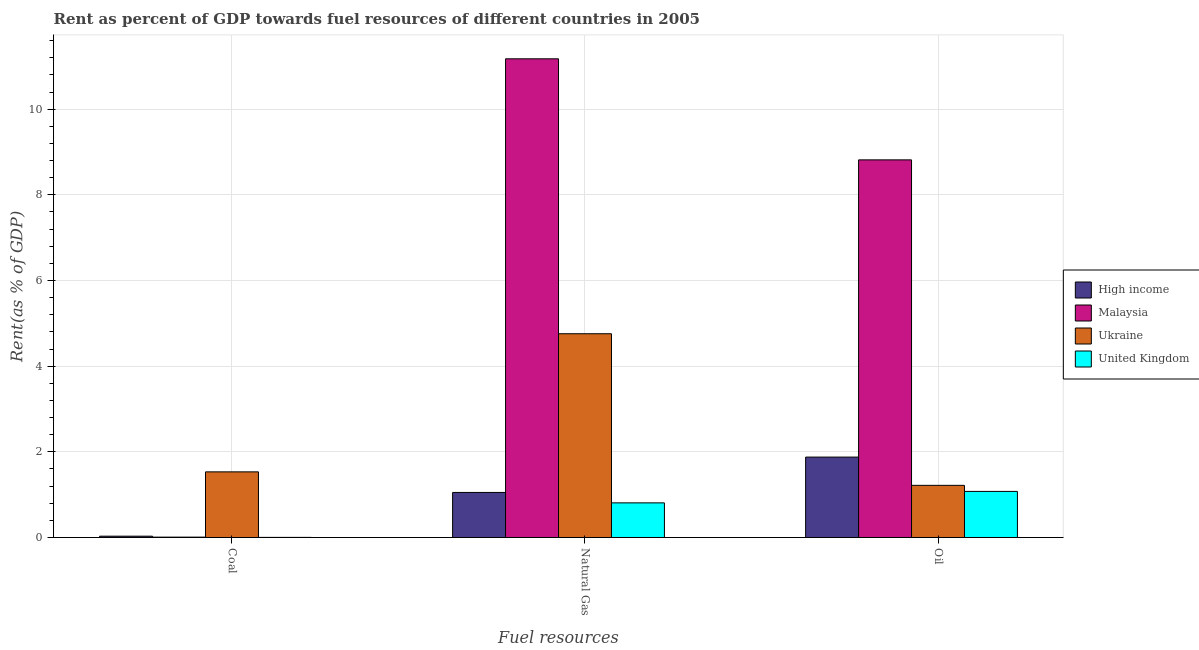How many bars are there on the 1st tick from the left?
Offer a very short reply. 4. What is the label of the 1st group of bars from the left?
Ensure brevity in your answer.  Coal. What is the rent towards coal in United Kingdom?
Make the answer very short. 0. Across all countries, what is the maximum rent towards coal?
Keep it short and to the point. 1.53. Across all countries, what is the minimum rent towards oil?
Offer a terse response. 1.08. In which country was the rent towards oil maximum?
Make the answer very short. Malaysia. What is the total rent towards natural gas in the graph?
Offer a very short reply. 17.79. What is the difference between the rent towards coal in Ukraine and that in Malaysia?
Give a very brief answer. 1.52. What is the difference between the rent towards natural gas in Ukraine and the rent towards oil in United Kingdom?
Provide a short and direct response. 3.68. What is the average rent towards natural gas per country?
Keep it short and to the point. 4.45. What is the difference between the rent towards coal and rent towards natural gas in Malaysia?
Give a very brief answer. -11.17. In how many countries, is the rent towards oil greater than 0.4 %?
Make the answer very short. 4. What is the ratio of the rent towards natural gas in High income to that in Malaysia?
Offer a very short reply. 0.09. Is the rent towards natural gas in United Kingdom less than that in Ukraine?
Keep it short and to the point. Yes. Is the difference between the rent towards coal in High income and United Kingdom greater than the difference between the rent towards natural gas in High income and United Kingdom?
Provide a short and direct response. No. What is the difference between the highest and the second highest rent towards oil?
Ensure brevity in your answer.  6.94. What is the difference between the highest and the lowest rent towards natural gas?
Give a very brief answer. 10.37. What does the 2nd bar from the left in Natural Gas represents?
Provide a short and direct response. Malaysia. What does the 2nd bar from the right in Oil represents?
Your response must be concise. Ukraine. Is it the case that in every country, the sum of the rent towards coal and rent towards natural gas is greater than the rent towards oil?
Give a very brief answer. No. How many bars are there?
Provide a short and direct response. 12. How many countries are there in the graph?
Provide a short and direct response. 4. What is the difference between two consecutive major ticks on the Y-axis?
Make the answer very short. 2. Does the graph contain any zero values?
Offer a very short reply. No. Where does the legend appear in the graph?
Provide a succinct answer. Center right. How many legend labels are there?
Offer a terse response. 4. How are the legend labels stacked?
Your answer should be very brief. Vertical. What is the title of the graph?
Make the answer very short. Rent as percent of GDP towards fuel resources of different countries in 2005. What is the label or title of the X-axis?
Offer a terse response. Fuel resources. What is the label or title of the Y-axis?
Give a very brief answer. Rent(as % of GDP). What is the Rent(as % of GDP) in High income in Coal?
Provide a succinct answer. 0.03. What is the Rent(as % of GDP) in Malaysia in Coal?
Your response must be concise. 0.01. What is the Rent(as % of GDP) of Ukraine in Coal?
Your response must be concise. 1.53. What is the Rent(as % of GDP) in United Kingdom in Coal?
Offer a terse response. 0. What is the Rent(as % of GDP) in High income in Natural Gas?
Your response must be concise. 1.05. What is the Rent(as % of GDP) of Malaysia in Natural Gas?
Give a very brief answer. 11.18. What is the Rent(as % of GDP) in Ukraine in Natural Gas?
Ensure brevity in your answer.  4.76. What is the Rent(as % of GDP) in United Kingdom in Natural Gas?
Offer a very short reply. 0.81. What is the Rent(as % of GDP) of High income in Oil?
Give a very brief answer. 1.88. What is the Rent(as % of GDP) in Malaysia in Oil?
Offer a terse response. 8.82. What is the Rent(as % of GDP) of Ukraine in Oil?
Offer a very short reply. 1.22. What is the Rent(as % of GDP) in United Kingdom in Oil?
Keep it short and to the point. 1.08. Across all Fuel resources, what is the maximum Rent(as % of GDP) of High income?
Give a very brief answer. 1.88. Across all Fuel resources, what is the maximum Rent(as % of GDP) of Malaysia?
Ensure brevity in your answer.  11.18. Across all Fuel resources, what is the maximum Rent(as % of GDP) in Ukraine?
Offer a terse response. 4.76. Across all Fuel resources, what is the maximum Rent(as % of GDP) of United Kingdom?
Provide a short and direct response. 1.08. Across all Fuel resources, what is the minimum Rent(as % of GDP) in High income?
Keep it short and to the point. 0.03. Across all Fuel resources, what is the minimum Rent(as % of GDP) of Malaysia?
Provide a short and direct response. 0.01. Across all Fuel resources, what is the minimum Rent(as % of GDP) of Ukraine?
Your response must be concise. 1.22. Across all Fuel resources, what is the minimum Rent(as % of GDP) in United Kingdom?
Offer a very short reply. 0. What is the total Rent(as % of GDP) in High income in the graph?
Offer a terse response. 2.96. What is the total Rent(as % of GDP) of Malaysia in the graph?
Your answer should be compact. 20. What is the total Rent(as % of GDP) in Ukraine in the graph?
Your answer should be compact. 7.51. What is the total Rent(as % of GDP) of United Kingdom in the graph?
Make the answer very short. 1.89. What is the difference between the Rent(as % of GDP) of High income in Coal and that in Natural Gas?
Your answer should be very brief. -1.02. What is the difference between the Rent(as % of GDP) in Malaysia in Coal and that in Natural Gas?
Provide a short and direct response. -11.17. What is the difference between the Rent(as % of GDP) of Ukraine in Coal and that in Natural Gas?
Provide a succinct answer. -3.22. What is the difference between the Rent(as % of GDP) of United Kingdom in Coal and that in Natural Gas?
Make the answer very short. -0.81. What is the difference between the Rent(as % of GDP) in High income in Coal and that in Oil?
Your answer should be very brief. -1.85. What is the difference between the Rent(as % of GDP) of Malaysia in Coal and that in Oil?
Provide a succinct answer. -8.81. What is the difference between the Rent(as % of GDP) of Ukraine in Coal and that in Oil?
Offer a very short reply. 0.31. What is the difference between the Rent(as % of GDP) of United Kingdom in Coal and that in Oil?
Make the answer very short. -1.07. What is the difference between the Rent(as % of GDP) of High income in Natural Gas and that in Oil?
Your response must be concise. -0.83. What is the difference between the Rent(as % of GDP) of Malaysia in Natural Gas and that in Oil?
Offer a very short reply. 2.36. What is the difference between the Rent(as % of GDP) in Ukraine in Natural Gas and that in Oil?
Ensure brevity in your answer.  3.54. What is the difference between the Rent(as % of GDP) in United Kingdom in Natural Gas and that in Oil?
Give a very brief answer. -0.27. What is the difference between the Rent(as % of GDP) of High income in Coal and the Rent(as % of GDP) of Malaysia in Natural Gas?
Keep it short and to the point. -11.14. What is the difference between the Rent(as % of GDP) in High income in Coal and the Rent(as % of GDP) in Ukraine in Natural Gas?
Offer a terse response. -4.73. What is the difference between the Rent(as % of GDP) in High income in Coal and the Rent(as % of GDP) in United Kingdom in Natural Gas?
Ensure brevity in your answer.  -0.78. What is the difference between the Rent(as % of GDP) in Malaysia in Coal and the Rent(as % of GDP) in Ukraine in Natural Gas?
Make the answer very short. -4.75. What is the difference between the Rent(as % of GDP) in Malaysia in Coal and the Rent(as % of GDP) in United Kingdom in Natural Gas?
Make the answer very short. -0.8. What is the difference between the Rent(as % of GDP) in Ukraine in Coal and the Rent(as % of GDP) in United Kingdom in Natural Gas?
Offer a very short reply. 0.72. What is the difference between the Rent(as % of GDP) of High income in Coal and the Rent(as % of GDP) of Malaysia in Oil?
Provide a short and direct response. -8.79. What is the difference between the Rent(as % of GDP) of High income in Coal and the Rent(as % of GDP) of Ukraine in Oil?
Ensure brevity in your answer.  -1.19. What is the difference between the Rent(as % of GDP) in High income in Coal and the Rent(as % of GDP) in United Kingdom in Oil?
Your answer should be very brief. -1.05. What is the difference between the Rent(as % of GDP) of Malaysia in Coal and the Rent(as % of GDP) of Ukraine in Oil?
Provide a succinct answer. -1.21. What is the difference between the Rent(as % of GDP) of Malaysia in Coal and the Rent(as % of GDP) of United Kingdom in Oil?
Ensure brevity in your answer.  -1.07. What is the difference between the Rent(as % of GDP) in Ukraine in Coal and the Rent(as % of GDP) in United Kingdom in Oil?
Give a very brief answer. 0.46. What is the difference between the Rent(as % of GDP) of High income in Natural Gas and the Rent(as % of GDP) of Malaysia in Oil?
Your response must be concise. -7.76. What is the difference between the Rent(as % of GDP) in High income in Natural Gas and the Rent(as % of GDP) in Ukraine in Oil?
Ensure brevity in your answer.  -0.17. What is the difference between the Rent(as % of GDP) of High income in Natural Gas and the Rent(as % of GDP) of United Kingdom in Oil?
Provide a short and direct response. -0.02. What is the difference between the Rent(as % of GDP) in Malaysia in Natural Gas and the Rent(as % of GDP) in Ukraine in Oil?
Your answer should be compact. 9.96. What is the difference between the Rent(as % of GDP) of Malaysia in Natural Gas and the Rent(as % of GDP) of United Kingdom in Oil?
Your response must be concise. 10.1. What is the difference between the Rent(as % of GDP) of Ukraine in Natural Gas and the Rent(as % of GDP) of United Kingdom in Oil?
Give a very brief answer. 3.68. What is the average Rent(as % of GDP) in High income per Fuel resources?
Your answer should be very brief. 0.99. What is the average Rent(as % of GDP) of Malaysia per Fuel resources?
Offer a very short reply. 6.67. What is the average Rent(as % of GDP) of Ukraine per Fuel resources?
Your response must be concise. 2.5. What is the average Rent(as % of GDP) in United Kingdom per Fuel resources?
Give a very brief answer. 0.63. What is the difference between the Rent(as % of GDP) in High income and Rent(as % of GDP) in Malaysia in Coal?
Offer a terse response. 0.02. What is the difference between the Rent(as % of GDP) in High income and Rent(as % of GDP) in Ukraine in Coal?
Provide a short and direct response. -1.5. What is the difference between the Rent(as % of GDP) in High income and Rent(as % of GDP) in United Kingdom in Coal?
Give a very brief answer. 0.03. What is the difference between the Rent(as % of GDP) of Malaysia and Rent(as % of GDP) of Ukraine in Coal?
Your answer should be very brief. -1.52. What is the difference between the Rent(as % of GDP) in Malaysia and Rent(as % of GDP) in United Kingdom in Coal?
Ensure brevity in your answer.  0.01. What is the difference between the Rent(as % of GDP) in Ukraine and Rent(as % of GDP) in United Kingdom in Coal?
Ensure brevity in your answer.  1.53. What is the difference between the Rent(as % of GDP) of High income and Rent(as % of GDP) of Malaysia in Natural Gas?
Keep it short and to the point. -10.12. What is the difference between the Rent(as % of GDP) of High income and Rent(as % of GDP) of Ukraine in Natural Gas?
Your response must be concise. -3.7. What is the difference between the Rent(as % of GDP) of High income and Rent(as % of GDP) of United Kingdom in Natural Gas?
Your answer should be compact. 0.24. What is the difference between the Rent(as % of GDP) of Malaysia and Rent(as % of GDP) of Ukraine in Natural Gas?
Give a very brief answer. 6.42. What is the difference between the Rent(as % of GDP) in Malaysia and Rent(as % of GDP) in United Kingdom in Natural Gas?
Provide a short and direct response. 10.37. What is the difference between the Rent(as % of GDP) of Ukraine and Rent(as % of GDP) of United Kingdom in Natural Gas?
Ensure brevity in your answer.  3.95. What is the difference between the Rent(as % of GDP) in High income and Rent(as % of GDP) in Malaysia in Oil?
Your answer should be compact. -6.94. What is the difference between the Rent(as % of GDP) in High income and Rent(as % of GDP) in Ukraine in Oil?
Offer a very short reply. 0.66. What is the difference between the Rent(as % of GDP) of High income and Rent(as % of GDP) of United Kingdom in Oil?
Offer a very short reply. 0.8. What is the difference between the Rent(as % of GDP) of Malaysia and Rent(as % of GDP) of Ukraine in Oil?
Offer a very short reply. 7.6. What is the difference between the Rent(as % of GDP) of Malaysia and Rent(as % of GDP) of United Kingdom in Oil?
Keep it short and to the point. 7.74. What is the difference between the Rent(as % of GDP) in Ukraine and Rent(as % of GDP) in United Kingdom in Oil?
Offer a very short reply. 0.14. What is the ratio of the Rent(as % of GDP) of High income in Coal to that in Natural Gas?
Offer a very short reply. 0.03. What is the ratio of the Rent(as % of GDP) in Malaysia in Coal to that in Natural Gas?
Ensure brevity in your answer.  0. What is the ratio of the Rent(as % of GDP) in Ukraine in Coal to that in Natural Gas?
Keep it short and to the point. 0.32. What is the ratio of the Rent(as % of GDP) in United Kingdom in Coal to that in Natural Gas?
Your response must be concise. 0. What is the ratio of the Rent(as % of GDP) of High income in Coal to that in Oil?
Provide a short and direct response. 0.02. What is the ratio of the Rent(as % of GDP) of Malaysia in Coal to that in Oil?
Offer a very short reply. 0. What is the ratio of the Rent(as % of GDP) in Ukraine in Coal to that in Oil?
Your answer should be very brief. 1.26. What is the ratio of the Rent(as % of GDP) in United Kingdom in Coal to that in Oil?
Provide a short and direct response. 0. What is the ratio of the Rent(as % of GDP) in High income in Natural Gas to that in Oil?
Your answer should be compact. 0.56. What is the ratio of the Rent(as % of GDP) in Malaysia in Natural Gas to that in Oil?
Keep it short and to the point. 1.27. What is the ratio of the Rent(as % of GDP) of Ukraine in Natural Gas to that in Oil?
Make the answer very short. 3.91. What is the ratio of the Rent(as % of GDP) of United Kingdom in Natural Gas to that in Oil?
Offer a very short reply. 0.75. What is the difference between the highest and the second highest Rent(as % of GDP) in High income?
Keep it short and to the point. 0.83. What is the difference between the highest and the second highest Rent(as % of GDP) in Malaysia?
Provide a short and direct response. 2.36. What is the difference between the highest and the second highest Rent(as % of GDP) in Ukraine?
Ensure brevity in your answer.  3.22. What is the difference between the highest and the second highest Rent(as % of GDP) of United Kingdom?
Keep it short and to the point. 0.27. What is the difference between the highest and the lowest Rent(as % of GDP) in High income?
Provide a short and direct response. 1.85. What is the difference between the highest and the lowest Rent(as % of GDP) of Malaysia?
Your answer should be compact. 11.17. What is the difference between the highest and the lowest Rent(as % of GDP) of Ukraine?
Your response must be concise. 3.54. What is the difference between the highest and the lowest Rent(as % of GDP) of United Kingdom?
Make the answer very short. 1.07. 